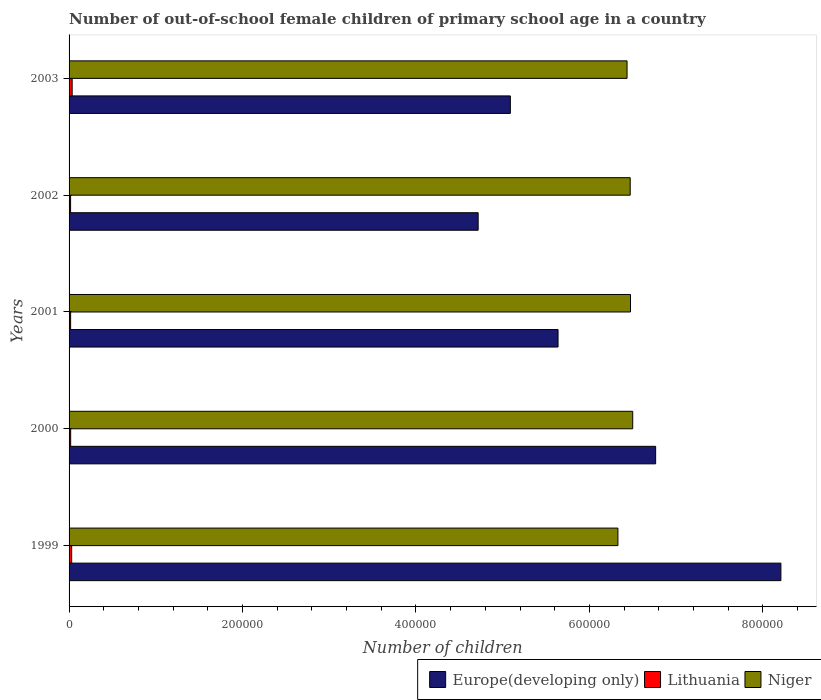How many bars are there on the 3rd tick from the top?
Give a very brief answer. 3. What is the label of the 5th group of bars from the top?
Provide a short and direct response. 1999. In how many cases, is the number of bars for a given year not equal to the number of legend labels?
Provide a short and direct response. 0. What is the number of out-of-school female children in Lithuania in 2001?
Your response must be concise. 1798. Across all years, what is the maximum number of out-of-school female children in Lithuania?
Give a very brief answer. 3560. Across all years, what is the minimum number of out-of-school female children in Niger?
Offer a very short reply. 6.33e+05. In which year was the number of out-of-school female children in Lithuania maximum?
Make the answer very short. 2003. In which year was the number of out-of-school female children in Lithuania minimum?
Your answer should be very brief. 2002. What is the total number of out-of-school female children in Europe(developing only) in the graph?
Make the answer very short. 3.04e+06. What is the difference between the number of out-of-school female children in Lithuania in 2000 and that in 2002?
Your answer should be compact. 102. What is the difference between the number of out-of-school female children in Niger in 2001 and the number of out-of-school female children in Europe(developing only) in 1999?
Provide a succinct answer. -1.73e+05. What is the average number of out-of-school female children in Niger per year?
Your response must be concise. 6.44e+05. In the year 2001, what is the difference between the number of out-of-school female children in Niger and number of out-of-school female children in Lithuania?
Keep it short and to the point. 6.46e+05. In how many years, is the number of out-of-school female children in Lithuania greater than 360000 ?
Provide a succinct answer. 0. What is the ratio of the number of out-of-school female children in Europe(developing only) in 2002 to that in 2003?
Give a very brief answer. 0.93. Is the number of out-of-school female children in Lithuania in 2000 less than that in 2001?
Make the answer very short. No. What is the difference between the highest and the second highest number of out-of-school female children in Europe(developing only)?
Offer a very short reply. 1.44e+05. What is the difference between the highest and the lowest number of out-of-school female children in Niger?
Make the answer very short. 1.71e+04. In how many years, is the number of out-of-school female children in Niger greater than the average number of out-of-school female children in Niger taken over all years?
Offer a very short reply. 3. What does the 1st bar from the top in 2003 represents?
Make the answer very short. Niger. What does the 1st bar from the bottom in 2000 represents?
Ensure brevity in your answer.  Europe(developing only). Is it the case that in every year, the sum of the number of out-of-school female children in Europe(developing only) and number of out-of-school female children in Niger is greater than the number of out-of-school female children in Lithuania?
Your response must be concise. Yes. How many bars are there?
Your answer should be compact. 15. Are all the bars in the graph horizontal?
Ensure brevity in your answer.  Yes. How many years are there in the graph?
Your response must be concise. 5. What is the difference between two consecutive major ticks on the X-axis?
Give a very brief answer. 2.00e+05. Does the graph contain any zero values?
Ensure brevity in your answer.  No. Does the graph contain grids?
Give a very brief answer. No. How are the legend labels stacked?
Make the answer very short. Horizontal. What is the title of the graph?
Ensure brevity in your answer.  Number of out-of-school female children of primary school age in a country. What is the label or title of the X-axis?
Provide a succinct answer. Number of children. What is the label or title of the Y-axis?
Provide a succinct answer. Years. What is the Number of children in Europe(developing only) in 1999?
Your answer should be very brief. 8.21e+05. What is the Number of children in Lithuania in 1999?
Your response must be concise. 2998. What is the Number of children of Niger in 1999?
Your answer should be very brief. 6.33e+05. What is the Number of children of Europe(developing only) in 2000?
Your response must be concise. 6.76e+05. What is the Number of children of Lithuania in 2000?
Ensure brevity in your answer.  1849. What is the Number of children in Niger in 2000?
Your answer should be compact. 6.50e+05. What is the Number of children of Europe(developing only) in 2001?
Your answer should be compact. 5.64e+05. What is the Number of children of Lithuania in 2001?
Offer a very short reply. 1798. What is the Number of children in Niger in 2001?
Provide a succinct answer. 6.47e+05. What is the Number of children in Europe(developing only) in 2002?
Make the answer very short. 4.72e+05. What is the Number of children of Lithuania in 2002?
Give a very brief answer. 1747. What is the Number of children in Niger in 2002?
Offer a very short reply. 6.47e+05. What is the Number of children of Europe(developing only) in 2003?
Provide a short and direct response. 5.09e+05. What is the Number of children of Lithuania in 2003?
Provide a succinct answer. 3560. What is the Number of children of Niger in 2003?
Ensure brevity in your answer.  6.43e+05. Across all years, what is the maximum Number of children of Europe(developing only)?
Ensure brevity in your answer.  8.21e+05. Across all years, what is the maximum Number of children in Lithuania?
Offer a terse response. 3560. Across all years, what is the maximum Number of children in Niger?
Provide a succinct answer. 6.50e+05. Across all years, what is the minimum Number of children in Europe(developing only)?
Provide a short and direct response. 4.72e+05. Across all years, what is the minimum Number of children in Lithuania?
Your answer should be compact. 1747. Across all years, what is the minimum Number of children in Niger?
Make the answer very short. 6.33e+05. What is the total Number of children of Europe(developing only) in the graph?
Provide a short and direct response. 3.04e+06. What is the total Number of children of Lithuania in the graph?
Keep it short and to the point. 1.20e+04. What is the total Number of children of Niger in the graph?
Keep it short and to the point. 3.22e+06. What is the difference between the Number of children in Europe(developing only) in 1999 and that in 2000?
Your response must be concise. 1.44e+05. What is the difference between the Number of children of Lithuania in 1999 and that in 2000?
Make the answer very short. 1149. What is the difference between the Number of children in Niger in 1999 and that in 2000?
Provide a short and direct response. -1.71e+04. What is the difference between the Number of children in Europe(developing only) in 1999 and that in 2001?
Provide a succinct answer. 2.57e+05. What is the difference between the Number of children of Lithuania in 1999 and that in 2001?
Provide a short and direct response. 1200. What is the difference between the Number of children of Niger in 1999 and that in 2001?
Give a very brief answer. -1.45e+04. What is the difference between the Number of children of Europe(developing only) in 1999 and that in 2002?
Your response must be concise. 3.49e+05. What is the difference between the Number of children in Lithuania in 1999 and that in 2002?
Provide a short and direct response. 1251. What is the difference between the Number of children in Niger in 1999 and that in 2002?
Offer a terse response. -1.42e+04. What is the difference between the Number of children of Europe(developing only) in 1999 and that in 2003?
Offer a terse response. 3.12e+05. What is the difference between the Number of children in Lithuania in 1999 and that in 2003?
Give a very brief answer. -562. What is the difference between the Number of children of Niger in 1999 and that in 2003?
Ensure brevity in your answer.  -1.05e+04. What is the difference between the Number of children in Europe(developing only) in 2000 and that in 2001?
Provide a succinct answer. 1.13e+05. What is the difference between the Number of children of Lithuania in 2000 and that in 2001?
Give a very brief answer. 51. What is the difference between the Number of children in Niger in 2000 and that in 2001?
Your answer should be very brief. 2564. What is the difference between the Number of children in Europe(developing only) in 2000 and that in 2002?
Keep it short and to the point. 2.05e+05. What is the difference between the Number of children in Lithuania in 2000 and that in 2002?
Make the answer very short. 102. What is the difference between the Number of children in Niger in 2000 and that in 2002?
Provide a short and direct response. 2904. What is the difference between the Number of children of Europe(developing only) in 2000 and that in 2003?
Offer a very short reply. 1.68e+05. What is the difference between the Number of children of Lithuania in 2000 and that in 2003?
Your answer should be very brief. -1711. What is the difference between the Number of children of Niger in 2000 and that in 2003?
Your answer should be very brief. 6531. What is the difference between the Number of children in Europe(developing only) in 2001 and that in 2002?
Offer a terse response. 9.21e+04. What is the difference between the Number of children in Lithuania in 2001 and that in 2002?
Ensure brevity in your answer.  51. What is the difference between the Number of children in Niger in 2001 and that in 2002?
Offer a terse response. 340. What is the difference between the Number of children of Europe(developing only) in 2001 and that in 2003?
Offer a very short reply. 5.50e+04. What is the difference between the Number of children of Lithuania in 2001 and that in 2003?
Your answer should be very brief. -1762. What is the difference between the Number of children in Niger in 2001 and that in 2003?
Make the answer very short. 3967. What is the difference between the Number of children in Europe(developing only) in 2002 and that in 2003?
Offer a terse response. -3.71e+04. What is the difference between the Number of children of Lithuania in 2002 and that in 2003?
Your response must be concise. -1813. What is the difference between the Number of children in Niger in 2002 and that in 2003?
Offer a terse response. 3627. What is the difference between the Number of children in Europe(developing only) in 1999 and the Number of children in Lithuania in 2000?
Keep it short and to the point. 8.19e+05. What is the difference between the Number of children in Europe(developing only) in 1999 and the Number of children in Niger in 2000?
Offer a very short reply. 1.71e+05. What is the difference between the Number of children of Lithuania in 1999 and the Number of children of Niger in 2000?
Ensure brevity in your answer.  -6.47e+05. What is the difference between the Number of children of Europe(developing only) in 1999 and the Number of children of Lithuania in 2001?
Provide a succinct answer. 8.19e+05. What is the difference between the Number of children of Europe(developing only) in 1999 and the Number of children of Niger in 2001?
Your answer should be compact. 1.73e+05. What is the difference between the Number of children of Lithuania in 1999 and the Number of children of Niger in 2001?
Keep it short and to the point. -6.44e+05. What is the difference between the Number of children in Europe(developing only) in 1999 and the Number of children in Lithuania in 2002?
Offer a terse response. 8.19e+05. What is the difference between the Number of children in Europe(developing only) in 1999 and the Number of children in Niger in 2002?
Your answer should be very brief. 1.74e+05. What is the difference between the Number of children of Lithuania in 1999 and the Number of children of Niger in 2002?
Your answer should be very brief. -6.44e+05. What is the difference between the Number of children of Europe(developing only) in 1999 and the Number of children of Lithuania in 2003?
Provide a short and direct response. 8.17e+05. What is the difference between the Number of children of Europe(developing only) in 1999 and the Number of children of Niger in 2003?
Provide a short and direct response. 1.77e+05. What is the difference between the Number of children of Lithuania in 1999 and the Number of children of Niger in 2003?
Provide a succinct answer. -6.40e+05. What is the difference between the Number of children in Europe(developing only) in 2000 and the Number of children in Lithuania in 2001?
Provide a short and direct response. 6.75e+05. What is the difference between the Number of children in Europe(developing only) in 2000 and the Number of children in Niger in 2001?
Make the answer very short. 2.90e+04. What is the difference between the Number of children in Lithuania in 2000 and the Number of children in Niger in 2001?
Provide a succinct answer. -6.45e+05. What is the difference between the Number of children in Europe(developing only) in 2000 and the Number of children in Lithuania in 2002?
Your answer should be compact. 6.75e+05. What is the difference between the Number of children of Europe(developing only) in 2000 and the Number of children of Niger in 2002?
Your answer should be compact. 2.93e+04. What is the difference between the Number of children in Lithuania in 2000 and the Number of children in Niger in 2002?
Provide a short and direct response. -6.45e+05. What is the difference between the Number of children of Europe(developing only) in 2000 and the Number of children of Lithuania in 2003?
Your response must be concise. 6.73e+05. What is the difference between the Number of children in Europe(developing only) in 2000 and the Number of children in Niger in 2003?
Make the answer very short. 3.30e+04. What is the difference between the Number of children of Lithuania in 2000 and the Number of children of Niger in 2003?
Give a very brief answer. -6.42e+05. What is the difference between the Number of children in Europe(developing only) in 2001 and the Number of children in Lithuania in 2002?
Keep it short and to the point. 5.62e+05. What is the difference between the Number of children of Europe(developing only) in 2001 and the Number of children of Niger in 2002?
Your answer should be very brief. -8.32e+04. What is the difference between the Number of children of Lithuania in 2001 and the Number of children of Niger in 2002?
Offer a terse response. -6.45e+05. What is the difference between the Number of children of Europe(developing only) in 2001 and the Number of children of Lithuania in 2003?
Make the answer very short. 5.60e+05. What is the difference between the Number of children in Europe(developing only) in 2001 and the Number of children in Niger in 2003?
Make the answer very short. -7.96e+04. What is the difference between the Number of children of Lithuania in 2001 and the Number of children of Niger in 2003?
Offer a very short reply. -6.42e+05. What is the difference between the Number of children of Europe(developing only) in 2002 and the Number of children of Lithuania in 2003?
Offer a terse response. 4.68e+05. What is the difference between the Number of children of Europe(developing only) in 2002 and the Number of children of Niger in 2003?
Give a very brief answer. -1.72e+05. What is the difference between the Number of children in Lithuania in 2002 and the Number of children in Niger in 2003?
Provide a short and direct response. -6.42e+05. What is the average Number of children of Europe(developing only) per year?
Give a very brief answer. 6.08e+05. What is the average Number of children in Lithuania per year?
Make the answer very short. 2390.4. What is the average Number of children in Niger per year?
Your answer should be very brief. 6.44e+05. In the year 1999, what is the difference between the Number of children of Europe(developing only) and Number of children of Lithuania?
Make the answer very short. 8.18e+05. In the year 1999, what is the difference between the Number of children in Europe(developing only) and Number of children in Niger?
Your response must be concise. 1.88e+05. In the year 1999, what is the difference between the Number of children of Lithuania and Number of children of Niger?
Offer a terse response. -6.30e+05. In the year 2000, what is the difference between the Number of children of Europe(developing only) and Number of children of Lithuania?
Offer a terse response. 6.74e+05. In the year 2000, what is the difference between the Number of children of Europe(developing only) and Number of children of Niger?
Offer a terse response. 2.64e+04. In the year 2000, what is the difference between the Number of children of Lithuania and Number of children of Niger?
Your answer should be very brief. -6.48e+05. In the year 2001, what is the difference between the Number of children in Europe(developing only) and Number of children in Lithuania?
Your answer should be compact. 5.62e+05. In the year 2001, what is the difference between the Number of children in Europe(developing only) and Number of children in Niger?
Offer a very short reply. -8.35e+04. In the year 2001, what is the difference between the Number of children in Lithuania and Number of children in Niger?
Your response must be concise. -6.46e+05. In the year 2002, what is the difference between the Number of children of Europe(developing only) and Number of children of Lithuania?
Your answer should be very brief. 4.70e+05. In the year 2002, what is the difference between the Number of children of Europe(developing only) and Number of children of Niger?
Offer a very short reply. -1.75e+05. In the year 2002, what is the difference between the Number of children of Lithuania and Number of children of Niger?
Provide a short and direct response. -6.45e+05. In the year 2003, what is the difference between the Number of children of Europe(developing only) and Number of children of Lithuania?
Your response must be concise. 5.05e+05. In the year 2003, what is the difference between the Number of children in Europe(developing only) and Number of children in Niger?
Provide a short and direct response. -1.35e+05. In the year 2003, what is the difference between the Number of children in Lithuania and Number of children in Niger?
Provide a short and direct response. -6.40e+05. What is the ratio of the Number of children in Europe(developing only) in 1999 to that in 2000?
Your answer should be very brief. 1.21. What is the ratio of the Number of children in Lithuania in 1999 to that in 2000?
Your answer should be compact. 1.62. What is the ratio of the Number of children of Niger in 1999 to that in 2000?
Make the answer very short. 0.97. What is the ratio of the Number of children of Europe(developing only) in 1999 to that in 2001?
Make the answer very short. 1.46. What is the ratio of the Number of children in Lithuania in 1999 to that in 2001?
Give a very brief answer. 1.67. What is the ratio of the Number of children of Niger in 1999 to that in 2001?
Provide a succinct answer. 0.98. What is the ratio of the Number of children of Europe(developing only) in 1999 to that in 2002?
Ensure brevity in your answer.  1.74. What is the ratio of the Number of children in Lithuania in 1999 to that in 2002?
Offer a terse response. 1.72. What is the ratio of the Number of children in Niger in 1999 to that in 2002?
Your answer should be very brief. 0.98. What is the ratio of the Number of children of Europe(developing only) in 1999 to that in 2003?
Keep it short and to the point. 1.61. What is the ratio of the Number of children in Lithuania in 1999 to that in 2003?
Your answer should be very brief. 0.84. What is the ratio of the Number of children of Niger in 1999 to that in 2003?
Keep it short and to the point. 0.98. What is the ratio of the Number of children in Europe(developing only) in 2000 to that in 2001?
Provide a succinct answer. 1.2. What is the ratio of the Number of children in Lithuania in 2000 to that in 2001?
Make the answer very short. 1.03. What is the ratio of the Number of children of Europe(developing only) in 2000 to that in 2002?
Keep it short and to the point. 1.43. What is the ratio of the Number of children of Lithuania in 2000 to that in 2002?
Provide a succinct answer. 1.06. What is the ratio of the Number of children of Niger in 2000 to that in 2002?
Offer a terse response. 1. What is the ratio of the Number of children in Europe(developing only) in 2000 to that in 2003?
Provide a short and direct response. 1.33. What is the ratio of the Number of children in Lithuania in 2000 to that in 2003?
Your answer should be very brief. 0.52. What is the ratio of the Number of children in Niger in 2000 to that in 2003?
Ensure brevity in your answer.  1.01. What is the ratio of the Number of children of Europe(developing only) in 2001 to that in 2002?
Provide a succinct answer. 1.2. What is the ratio of the Number of children in Lithuania in 2001 to that in 2002?
Make the answer very short. 1.03. What is the ratio of the Number of children in Europe(developing only) in 2001 to that in 2003?
Your response must be concise. 1.11. What is the ratio of the Number of children of Lithuania in 2001 to that in 2003?
Offer a very short reply. 0.51. What is the ratio of the Number of children in Niger in 2001 to that in 2003?
Ensure brevity in your answer.  1.01. What is the ratio of the Number of children in Europe(developing only) in 2002 to that in 2003?
Keep it short and to the point. 0.93. What is the ratio of the Number of children of Lithuania in 2002 to that in 2003?
Make the answer very short. 0.49. What is the ratio of the Number of children in Niger in 2002 to that in 2003?
Provide a succinct answer. 1.01. What is the difference between the highest and the second highest Number of children in Europe(developing only)?
Make the answer very short. 1.44e+05. What is the difference between the highest and the second highest Number of children in Lithuania?
Provide a succinct answer. 562. What is the difference between the highest and the second highest Number of children in Niger?
Give a very brief answer. 2564. What is the difference between the highest and the lowest Number of children in Europe(developing only)?
Your answer should be compact. 3.49e+05. What is the difference between the highest and the lowest Number of children of Lithuania?
Offer a very short reply. 1813. What is the difference between the highest and the lowest Number of children of Niger?
Offer a terse response. 1.71e+04. 